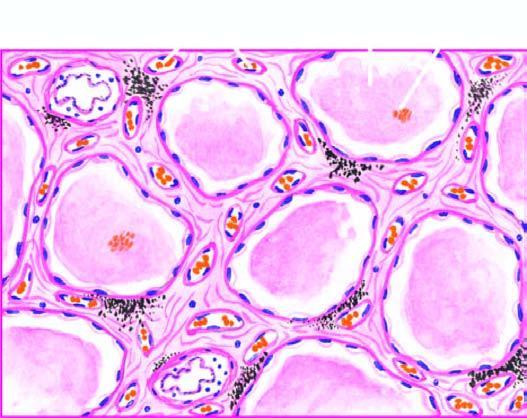re the alveolar capillaries congested?
Answer the question using a single word or phrase. Yes 